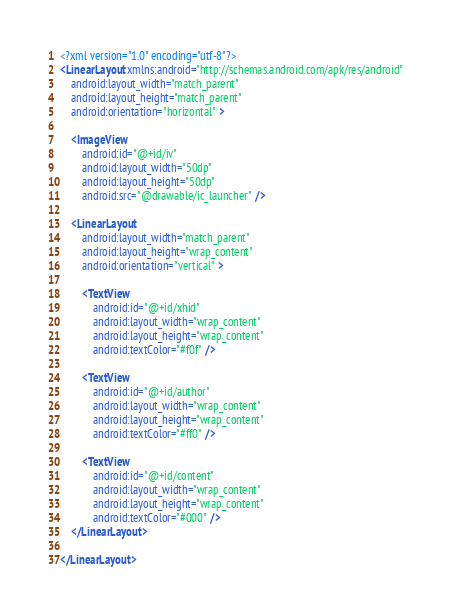<code> <loc_0><loc_0><loc_500><loc_500><_XML_><?xml version="1.0" encoding="utf-8"?>
<LinearLayout xmlns:android="http://schemas.android.com/apk/res/android"
    android:layout_width="match_parent"
    android:layout_height="match_parent"
    android:orientation="horizontal" >

    <ImageView
        android:id="@+id/iv"
        android:layout_width="50dp"
        android:layout_height="50dp"
        android:src="@drawable/ic_launcher" />

    <LinearLayout
        android:layout_width="match_parent"
        android:layout_height="wrap_content"
        android:orientation="vertical" >

        <TextView
            android:id="@+id/xhid"
            android:layout_width="wrap_content"
            android:layout_height="wrap_content"
            android:textColor="#f0f" />

        <TextView
            android:id="@+id/author"
            android:layout_width="wrap_content"
            android:layout_height="wrap_content"
            android:textColor="#ff0" />

        <TextView
            android:id="@+id/content"
            android:layout_width="wrap_content"
            android:layout_height="wrap_content"
            android:textColor="#000" />
    </LinearLayout>

</LinearLayout></code> 